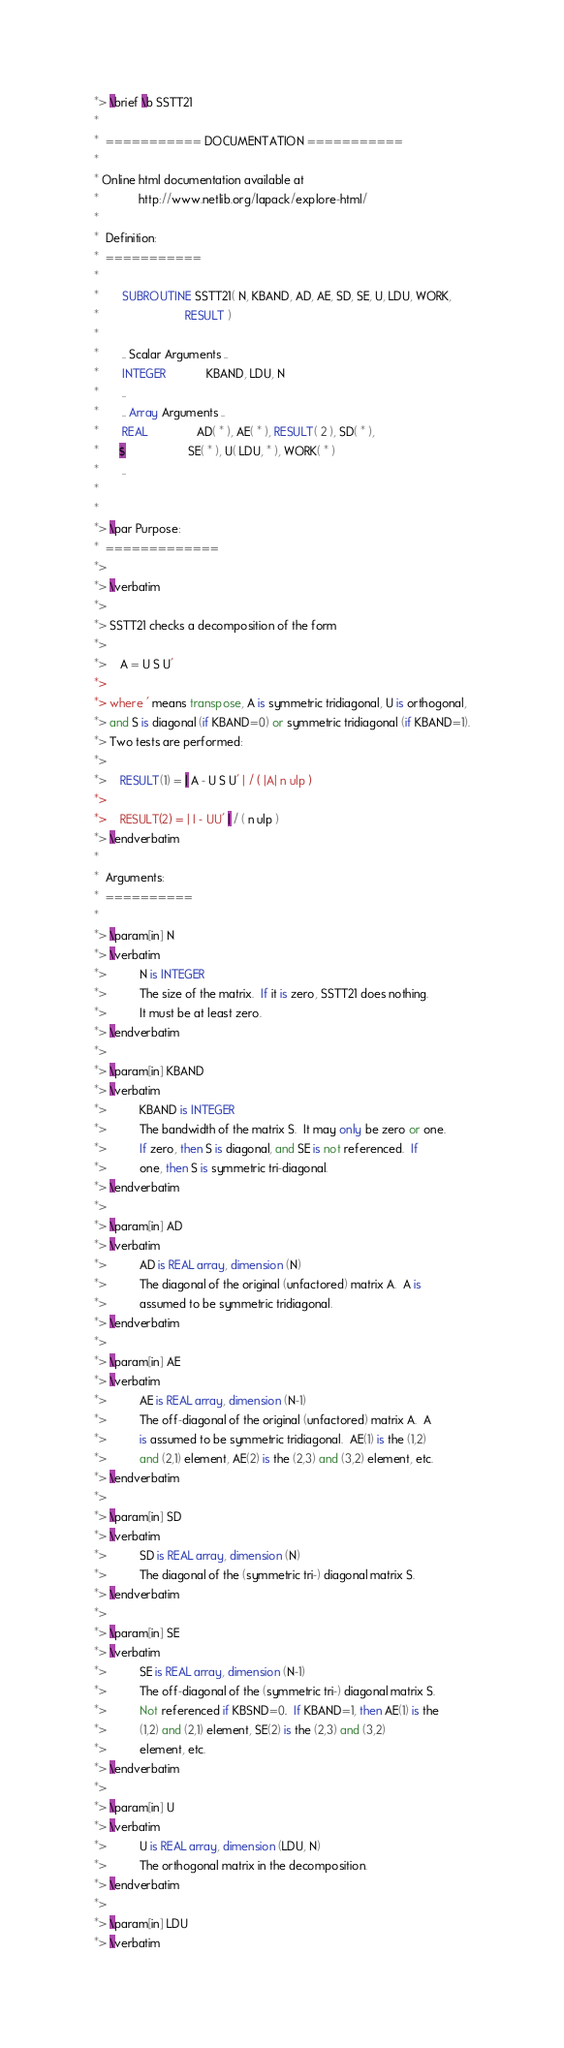<code> <loc_0><loc_0><loc_500><loc_500><_FORTRAN_>*> \brief \b SSTT21
*
*  =========== DOCUMENTATION ===========
*
* Online html documentation available at
*            http://www.netlib.org/lapack/explore-html/
*
*  Definition:
*  ===========
*
*       SUBROUTINE SSTT21( N, KBAND, AD, AE, SD, SE, U, LDU, WORK,
*                          RESULT )
*
*       .. Scalar Arguments ..
*       INTEGER            KBAND, LDU, N
*       ..
*       .. Array Arguments ..
*       REAL               AD( * ), AE( * ), RESULT( 2 ), SD( * ),
*      $                   SE( * ), U( LDU, * ), WORK( * )
*       ..
*
*
*> \par Purpose:
*  =============
*>
*> \verbatim
*>
*> SSTT21 checks a decomposition of the form
*>
*>    A = U S U'
*>
*> where ' means transpose, A is symmetric tridiagonal, U is orthogonal,
*> and S is diagonal (if KBAND=0) or symmetric tridiagonal (if KBAND=1).
*> Two tests are performed:
*>
*>    RESULT(1) = | A - U S U' | / ( |A| n ulp )
*>
*>    RESULT(2) = | I - UU' | / ( n ulp )
*> \endverbatim
*
*  Arguments:
*  ==========
*
*> \param[in] N
*> \verbatim
*>          N is INTEGER
*>          The size of the matrix.  If it is zero, SSTT21 does nothing.
*>          It must be at least zero.
*> \endverbatim
*>
*> \param[in] KBAND
*> \verbatim
*>          KBAND is INTEGER
*>          The bandwidth of the matrix S.  It may only be zero or one.
*>          If zero, then S is diagonal, and SE is not referenced.  If
*>          one, then S is symmetric tri-diagonal.
*> \endverbatim
*>
*> \param[in] AD
*> \verbatim
*>          AD is REAL array, dimension (N)
*>          The diagonal of the original (unfactored) matrix A.  A is
*>          assumed to be symmetric tridiagonal.
*> \endverbatim
*>
*> \param[in] AE
*> \verbatim
*>          AE is REAL array, dimension (N-1)
*>          The off-diagonal of the original (unfactored) matrix A.  A
*>          is assumed to be symmetric tridiagonal.  AE(1) is the (1,2)
*>          and (2,1) element, AE(2) is the (2,3) and (3,2) element, etc.
*> \endverbatim
*>
*> \param[in] SD
*> \verbatim
*>          SD is REAL array, dimension (N)
*>          The diagonal of the (symmetric tri-) diagonal matrix S.
*> \endverbatim
*>
*> \param[in] SE
*> \verbatim
*>          SE is REAL array, dimension (N-1)
*>          The off-diagonal of the (symmetric tri-) diagonal matrix S.
*>          Not referenced if KBSND=0.  If KBAND=1, then AE(1) is the
*>          (1,2) and (2,1) element, SE(2) is the (2,3) and (3,2)
*>          element, etc.
*> \endverbatim
*>
*> \param[in] U
*> \verbatim
*>          U is REAL array, dimension (LDU, N)
*>          The orthogonal matrix in the decomposition.
*> \endverbatim
*>
*> \param[in] LDU
*> \verbatim</code> 